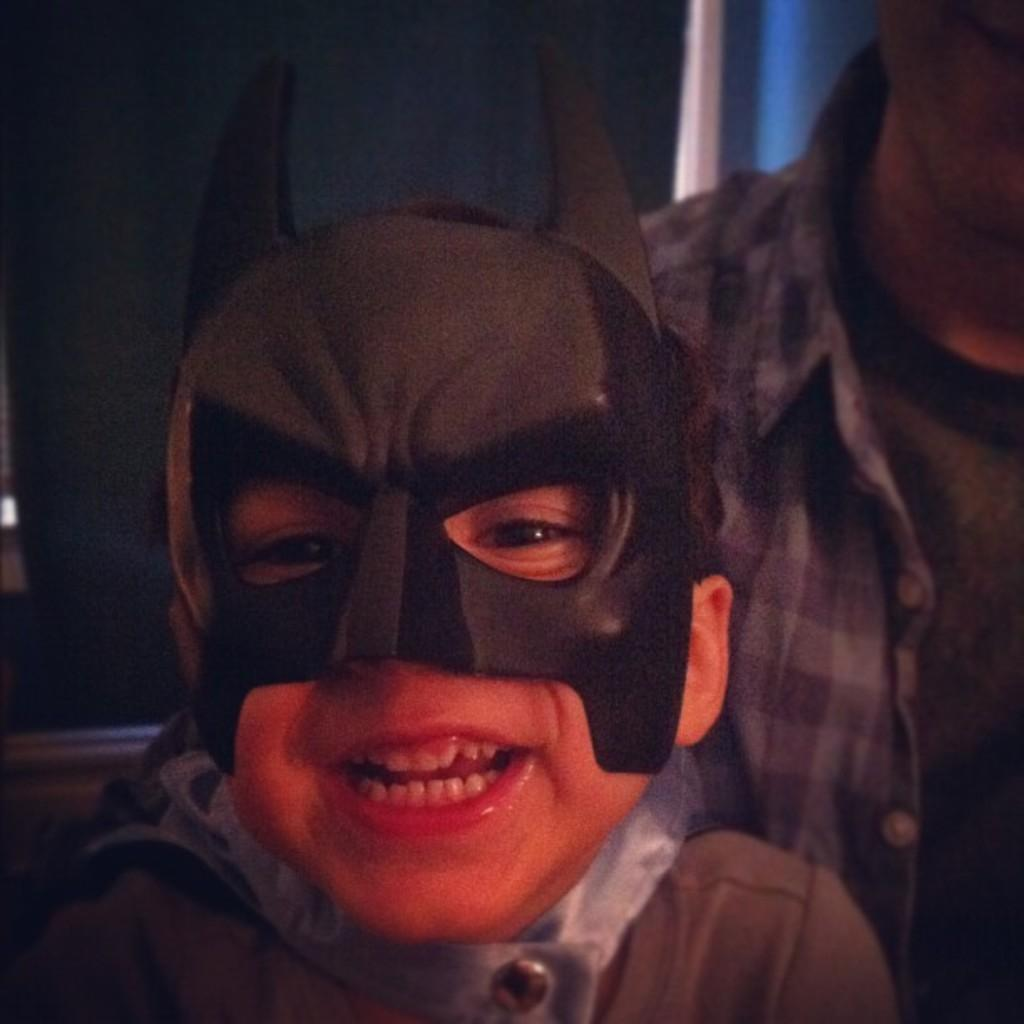What is the main subject in the foreground of the image? There is a person with a mask in the foreground of the image. Can you describe another person in the image? Yes, there is a man on the right side of the image. What can be seen in the background of the image? There appears to be a wall in the background of the image. What type of animals can be seen in the zoo in the image? There is no zoo present in the image; it features a person with a mask and a man near a wall. 